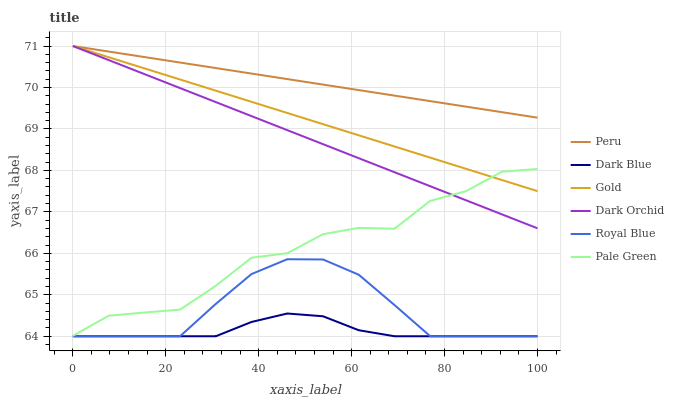Does Dark Blue have the minimum area under the curve?
Answer yes or no. Yes. Does Peru have the maximum area under the curve?
Answer yes or no. Yes. Does Royal Blue have the minimum area under the curve?
Answer yes or no. No. Does Royal Blue have the maximum area under the curve?
Answer yes or no. No. Is Dark Orchid the smoothest?
Answer yes or no. Yes. Is Pale Green the roughest?
Answer yes or no. Yes. Is Royal Blue the smoothest?
Answer yes or no. No. Is Royal Blue the roughest?
Answer yes or no. No. Does Dark Orchid have the lowest value?
Answer yes or no. No. Does Peru have the highest value?
Answer yes or no. Yes. Does Royal Blue have the highest value?
Answer yes or no. No. Is Dark Blue less than Dark Orchid?
Answer yes or no. Yes. Is Dark Orchid greater than Royal Blue?
Answer yes or no. Yes. Does Pale Green intersect Dark Orchid?
Answer yes or no. Yes. Is Pale Green less than Dark Orchid?
Answer yes or no. No. Is Pale Green greater than Dark Orchid?
Answer yes or no. No. Does Dark Blue intersect Dark Orchid?
Answer yes or no. No. 